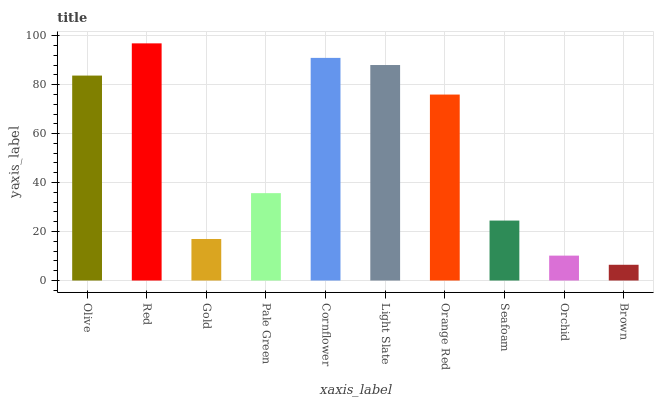Is Brown the minimum?
Answer yes or no. Yes. Is Red the maximum?
Answer yes or no. Yes. Is Gold the minimum?
Answer yes or no. No. Is Gold the maximum?
Answer yes or no. No. Is Red greater than Gold?
Answer yes or no. Yes. Is Gold less than Red?
Answer yes or no. Yes. Is Gold greater than Red?
Answer yes or no. No. Is Red less than Gold?
Answer yes or no. No. Is Orange Red the high median?
Answer yes or no. Yes. Is Pale Green the low median?
Answer yes or no. Yes. Is Gold the high median?
Answer yes or no. No. Is Cornflower the low median?
Answer yes or no. No. 